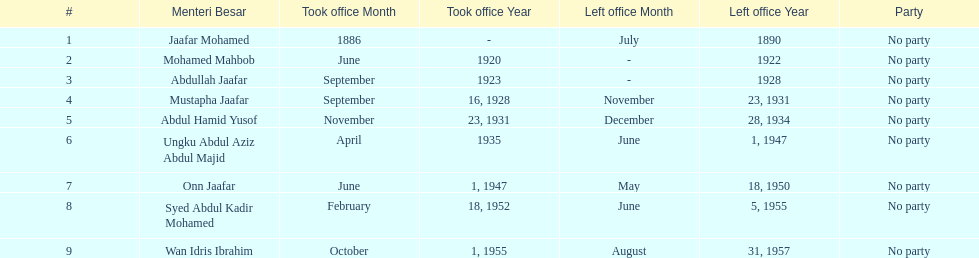Who was in office after mustapha jaafar Abdul Hamid Yusof. 